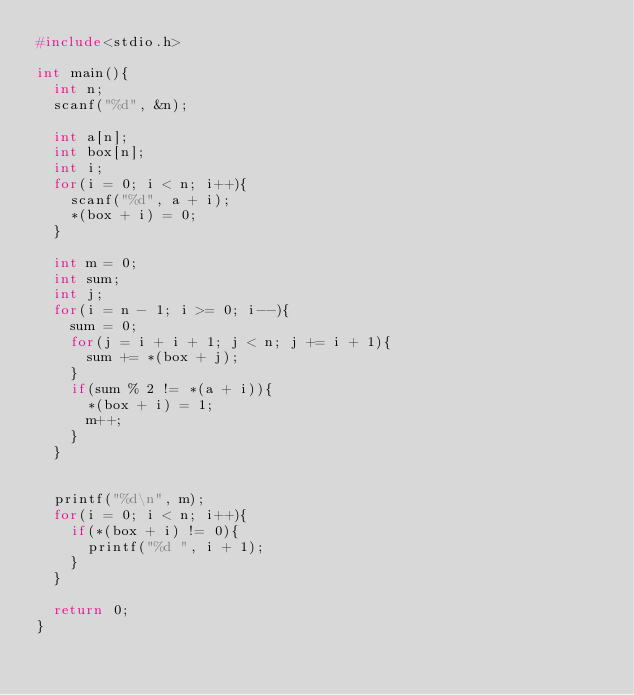Convert code to text. <code><loc_0><loc_0><loc_500><loc_500><_C_>#include<stdio.h>

int main(){
  int n;
  scanf("%d", &n);
  
  int a[n];
  int box[n];
  int i;
  for(i = 0; i < n; i++){
    scanf("%d", a + i);
    *(box + i) = 0;
  }
  
  int m = 0;
  int sum;
  int j;
  for(i = n - 1; i >= 0; i--){
    sum = 0;
    for(j = i + i + 1; j < n; j += i + 1){
      sum += *(box + j);
    }
    if(sum % 2 != *(a + i)){
      *(box + i) = 1;
      m++;
    }
  }
  
  
  printf("%d\n", m);
  for(i = 0; i < n; i++){
    if(*(box + i) != 0){
      printf("%d ", i + 1);
    }
  }
  
  return 0;
}
</code> 